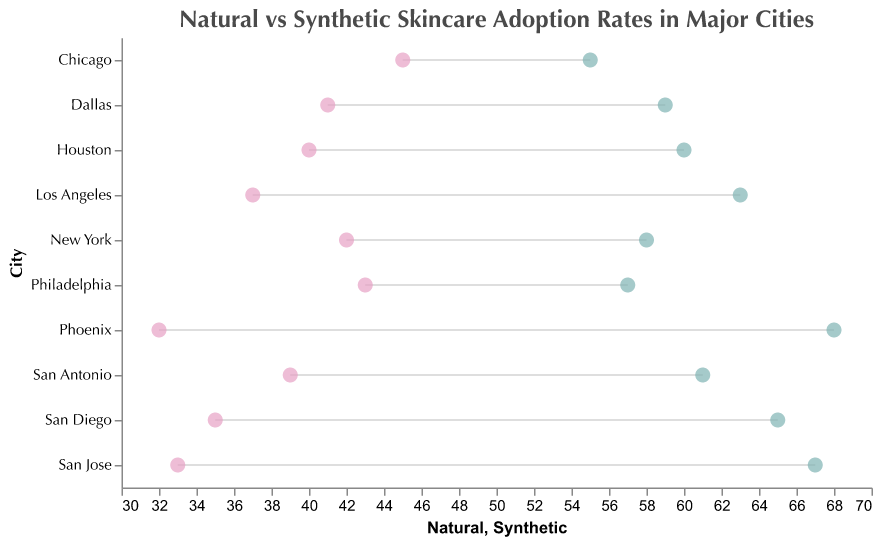What is the adoption rate of natural skincare remedies in New York? The plot shows that New York has a point indicating its natural skincare adoption rate, which is 58%.
Answer: 58% What is the difference in adoption rates between natural and synthetic skincare products in Phoenix? Measure the vertical difference between the two points representing Phoenix, where natural is 68% and synthetic is 32%, so the difference is 68% - 32% = 36%.
Answer: 36% Which city has the highest adoption rate of natural skincare remedies? By looking at the highest point in the Natural column, we see that Phoenix has the highest adoption rate at 68%.
Answer: Phoenix Among the cities listed, which one has a larger difference in adoption rates favoring synthetic skincare products? To find the city where synthetic adoption surpasses natural, calculate the difference between synthetic and natural for each city. Chicago has the largest difference (45% synthetic - 55% natural = -10%), noting the emphasis on synthetic.
Answer: Chicago What is the average adoption rate of natural skincare remedies across all cities? Add up all natural skincare adoption rates (58 + 63 + 55 + 60 + 68 + 57 + 61 + 65 + 59 + 67 = 613) and divide by the number of cities (10), which equals 613 / 10 = 61.3.
Answer: 61.3% Is there any city where the adoption rate of synthetic skincare products is higher than natural? For each city, compare the adoption rates of natural and synthetic. No city shows synthetic skincare adoption higher than natural.
Answer: No Between San Diego and Los Angeles, which city has a higher adoption rate of synthetic skincare products? Compare the adoption rates of synthetic skincare products: San Diego (35%) and Los Angeles (37%).
Answer: Los Angeles How does San Jose's adoption rate of natural skincare products compare to Dallas? San Jose's natural adoption rate is 67%, while Dallas has 59%. 67% is higher than 59%.
Answer: San Jose Which city has the smallest difference between the adoption rates of natural and synthetic skincare products? Calculate the difference for each city. Philadelphia has the smallest difference (57% natural - 43% synthetic = 14%).
Answer: Philadelphia 